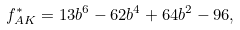<formula> <loc_0><loc_0><loc_500><loc_500>f ^ { * } _ { A K } = 1 3 b ^ { 6 } - 6 2 b ^ { 4 } + 6 4 b ^ { 2 } - 9 6 ,</formula> 